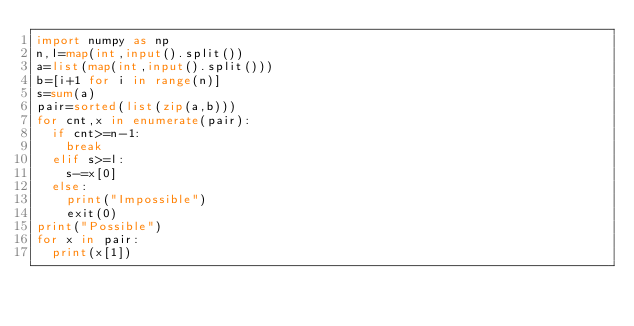<code> <loc_0><loc_0><loc_500><loc_500><_Python_>import numpy as np
n,l=map(int,input().split())
a=list(map(int,input().split()))
b=[i+1 for i in range(n)]
s=sum(a)
pair=sorted(list(zip(a,b)))
for cnt,x in enumerate(pair):
  if cnt>=n-1:
    break
  elif s>=l:
    s-=x[0]
  else:
    print("Impossible")
    exit(0)
print("Possible")
for x in pair:
  print(x[1])</code> 